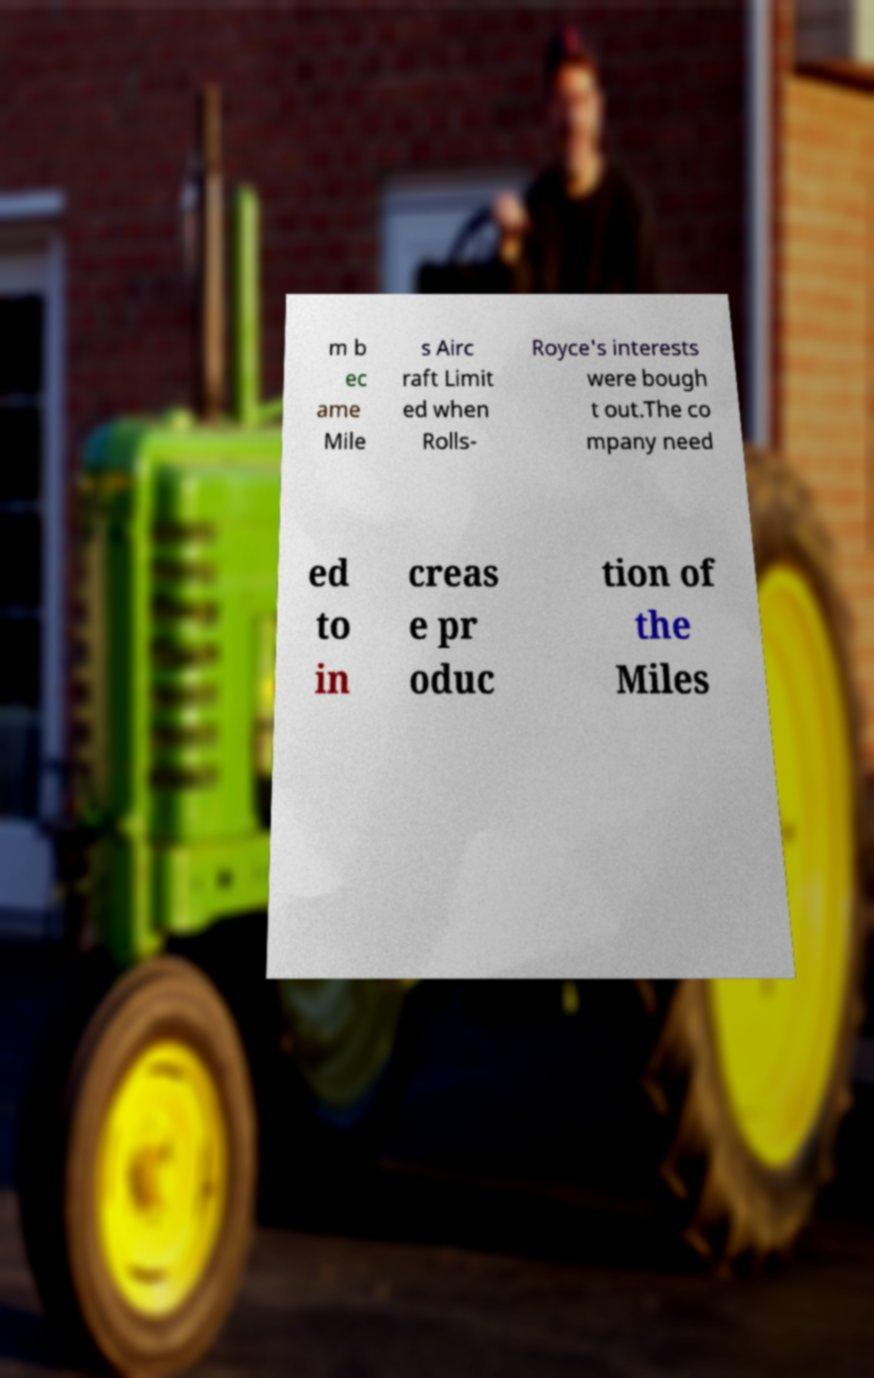Could you extract and type out the text from this image? m b ec ame Mile s Airc raft Limit ed when Rolls- Royce's interests were bough t out.The co mpany need ed to in creas e pr oduc tion of the Miles 